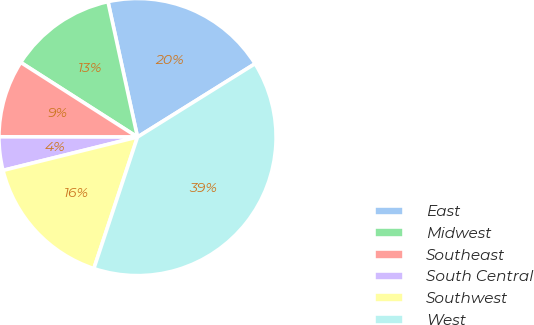Convert chart to OTSL. <chart><loc_0><loc_0><loc_500><loc_500><pie_chart><fcel>East<fcel>Midwest<fcel>Southeast<fcel>South Central<fcel>Southwest<fcel>West<nl><fcel>19.54%<fcel>12.53%<fcel>9.02%<fcel>3.9%<fcel>16.03%<fcel>38.98%<nl></chart> 